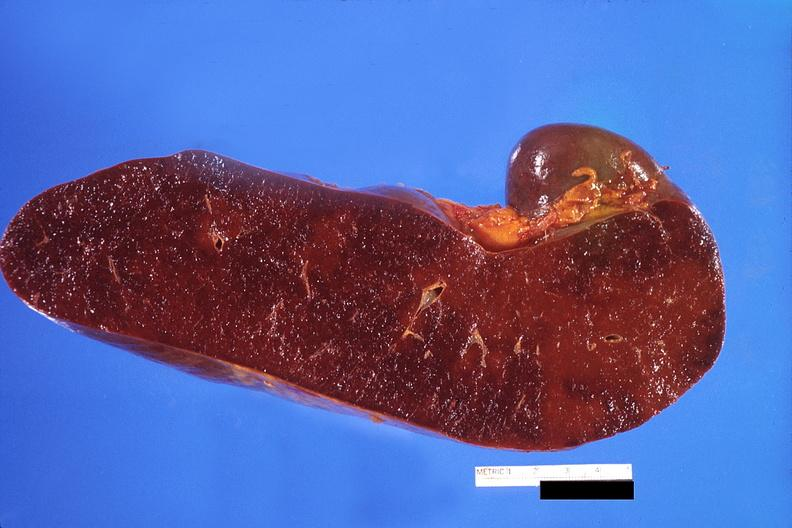s myocardial infarct present?
Answer the question using a single word or phrase. No 